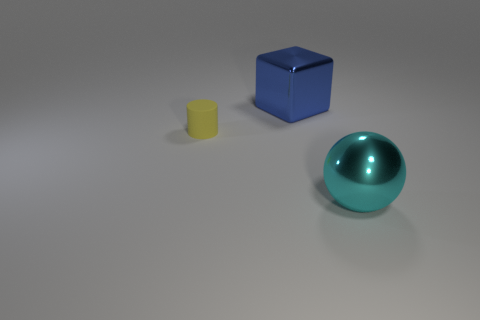There is a big thing that is behind the small object; what color is it?
Your answer should be very brief. Blue. The thing that is the same material as the blue cube is what size?
Ensure brevity in your answer.  Large. Are any small matte things visible?
Your answer should be very brief. Yes. What number of things are shiny things behind the big cyan ball or gray cylinders?
Give a very brief answer. 1. What material is the thing that is the same size as the cyan metal sphere?
Provide a succinct answer. Metal. What is the color of the big shiny object that is left of the large object in front of the small yellow rubber object?
Offer a very short reply. Blue. There is a cyan thing; what number of cubes are on the right side of it?
Make the answer very short. 0. What is the color of the big ball?
Give a very brief answer. Cyan. What number of tiny things are yellow objects or spheres?
Offer a very short reply. 1. How many other things are there of the same color as the large sphere?
Provide a short and direct response. 0. 